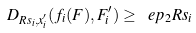<formula> <loc_0><loc_0><loc_500><loc_500>D _ { R s _ { i } , x ^ { \prime } _ { i } } ( f _ { i } ( F ) , F ^ { \prime } _ { i } ) \geq \ e p _ { 2 } R s _ { i }</formula> 